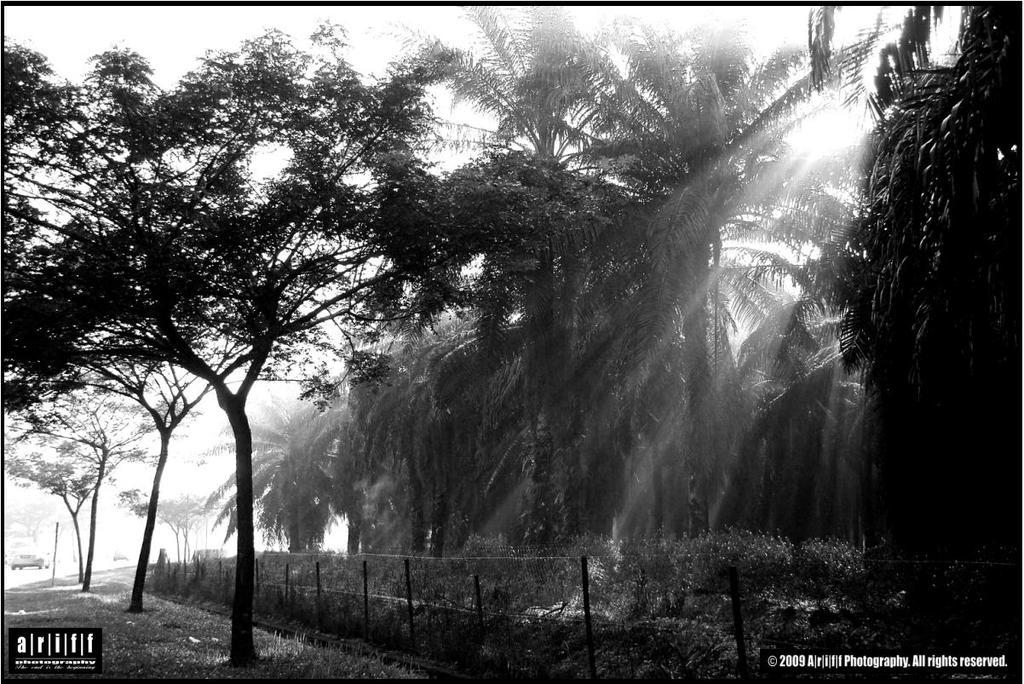What can be seen at the top of the image? The sky is visible in the image. What type of natural elements are present in the image? There are trees in the image. What is the source of light in the image? Sun rays are present in the image. What type of barrier can be seen in the image? There is a fence in the image. What is located far away in the image? A vehicle is visible in the distance. What type of imperfections are present at the bottom of the image? There are watermarks at the bottom portion of the image. How low can you swim in the image? There is no swimming or water present in the image. 